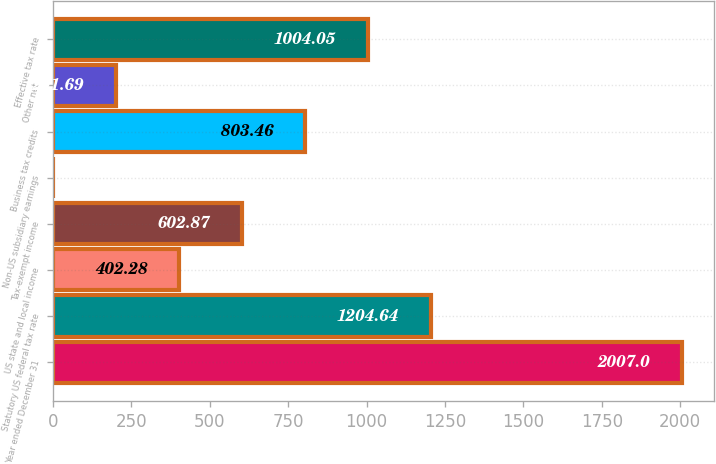Convert chart to OTSL. <chart><loc_0><loc_0><loc_500><loc_500><bar_chart><fcel>Year ended December 31<fcel>Statutory US federal tax rate<fcel>US state and local income<fcel>Tax-exempt income<fcel>Non-US subsidiary earnings<fcel>Business tax credits<fcel>Other net<fcel>Effective tax rate<nl><fcel>2007<fcel>1204.64<fcel>402.28<fcel>602.87<fcel>1.1<fcel>803.46<fcel>201.69<fcel>1004.05<nl></chart> 